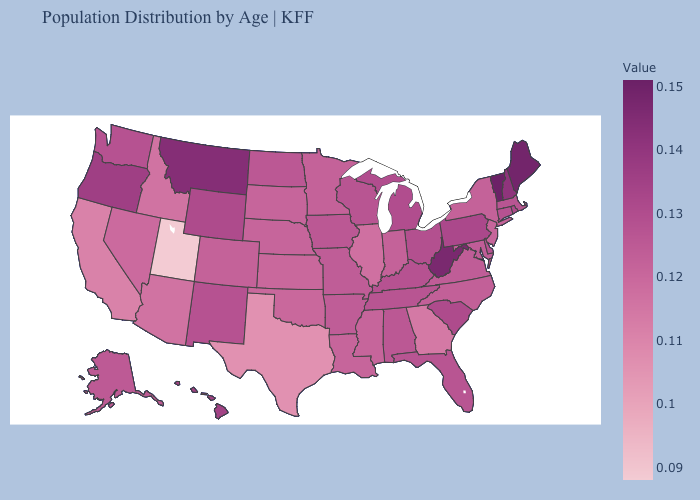Among the states that border Kentucky , does Illinois have the lowest value?
Keep it brief. Yes. Which states have the lowest value in the MidWest?
Keep it brief. Illinois. Which states have the lowest value in the MidWest?
Answer briefly. Illinois. Does Vermont have the highest value in the Northeast?
Keep it brief. Yes. Which states hav the highest value in the West?
Short answer required. Montana. Does Utah have the lowest value in the USA?
Short answer required. Yes. Which states have the highest value in the USA?
Quick response, please. Vermont. 